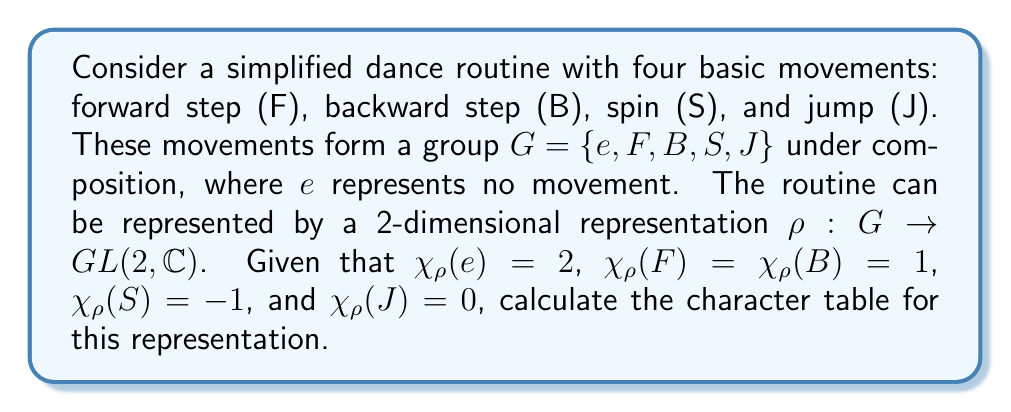Can you answer this question? To calculate the character table for this representation, we'll follow these steps:

1) First, let's identify the conjugacy classes of the group. In this case, each element forms its own conjugacy class: $\{e\}$, $\{F\}$, $\{B\}$, $\{S\}$, and $\{J\}$.

2) We know that the number of irreducible representations is equal to the number of conjugacy classes. So, we'll have 5 irreducible representations.

3) We're given the character values for our 2-dimensional representation $\rho$. Let's call this $\chi_2$:

   $\chi_2(e) = 2$, $\chi_2(F) = \chi_2(B) = 1$, $\chi_2(S) = -1$, $\chi_2(J) = 0$

4) The trivial representation $\chi_1$ always exists and has character 1 for all elements:

   $\chi_1(e) = \chi_1(F) = \chi_1(B) = \chi_1(S) = \chi_1(J) = 1$

5) To find the remaining representations, we can use the orthogonality relations and the fact that the sum of squares of dimensions of irreducible representations must equal the order of the group.

6) Let's assume there are three more 1-dimensional representations: $\chi_3$, $\chi_4$, and $\chi_5$.

7) Using the orthogonality relation with $\chi_1$ and $\chi_2$, we can deduce:

   $\chi_3(e) = \chi_4(e) = \chi_5(e) = 1$
   $\chi_3(F) + \chi_4(F) + \chi_5(F) = -1$
   $\chi_3(B) + \chi_4(B) + \chi_5(B) = -1$
   $\chi_3(S) + \chi_4(S) + \chi_5(S) = 1$
   $\chi_3(J) + \chi_4(J) + \chi_5(J) = -1$

8) One possible solution that satisfies these conditions is:

   $\chi_3: 1, 1, 1, -1, -1$
   $\chi_4: 1, -1, -1, 1, -1$
   $\chi_5: 1, -1, -1, 1, 1$

9) We can verify that these characters are orthogonal and that the sum of squares of dimensions equals the order of the group: $1^2 + 2^2 + 1^2 + 1^2 + 1^2 = 5$.

Therefore, the complete character table is:

$$
\begin{array}{c|ccccc}
   & e & F & B & S & J \\
\hline
\chi_1 & 1 & 1 & 1 & 1 & 1 \\
\chi_2 & 2 & 1 & 1 & -1 & 0 \\
\chi_3 & 1 & 1 & 1 & -1 & -1 \\
\chi_4 & 1 & -1 & -1 & 1 & -1 \\
\chi_5 & 1 & -1 & -1 & 1 & 1
\end{array}
$$
Answer: $$
\begin{array}{c|ccccc}
   & e & F & B & S & J \\
\hline
\chi_1 & 1 & 1 & 1 & 1 & 1 \\
\chi_2 & 2 & 1 & 1 & -1 & 0 \\
\chi_3 & 1 & 1 & 1 & -1 & -1 \\
\chi_4 & 1 & -1 & -1 & 1 & -1 \\
\chi_5 & 1 & -1 & -1 & 1 & 1
\end{array}
$$ 